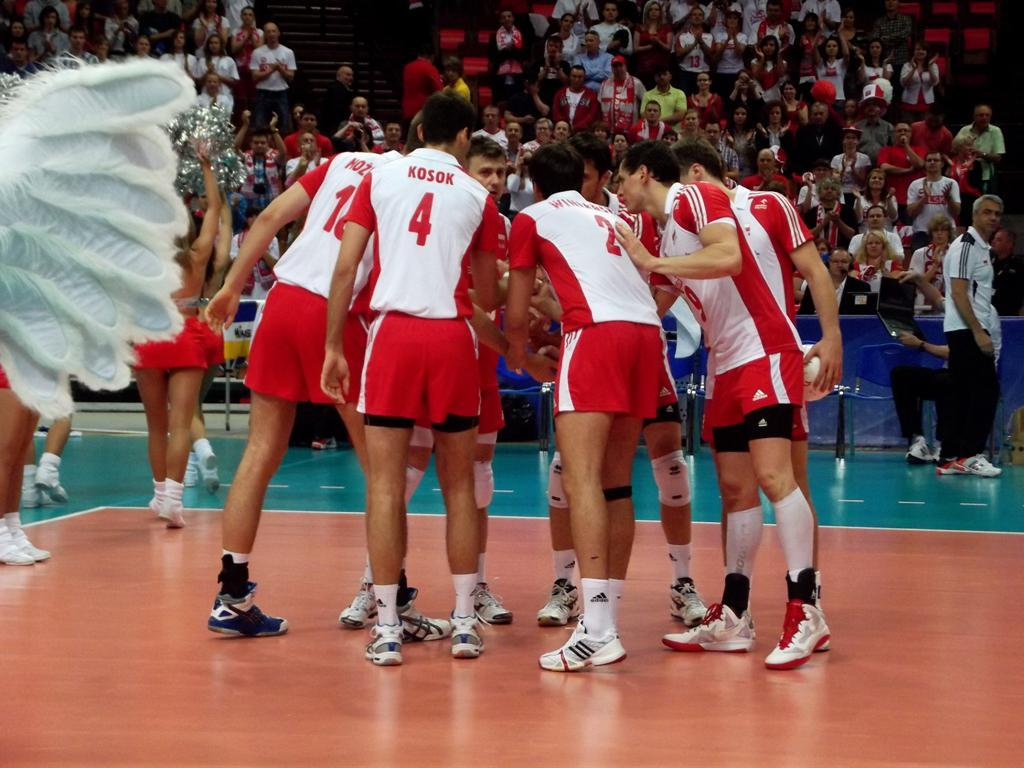<image>
Give a short and clear explanation of the subsequent image. Kosok is wearing a white and red shirt and was given the number 4 as his team number. 